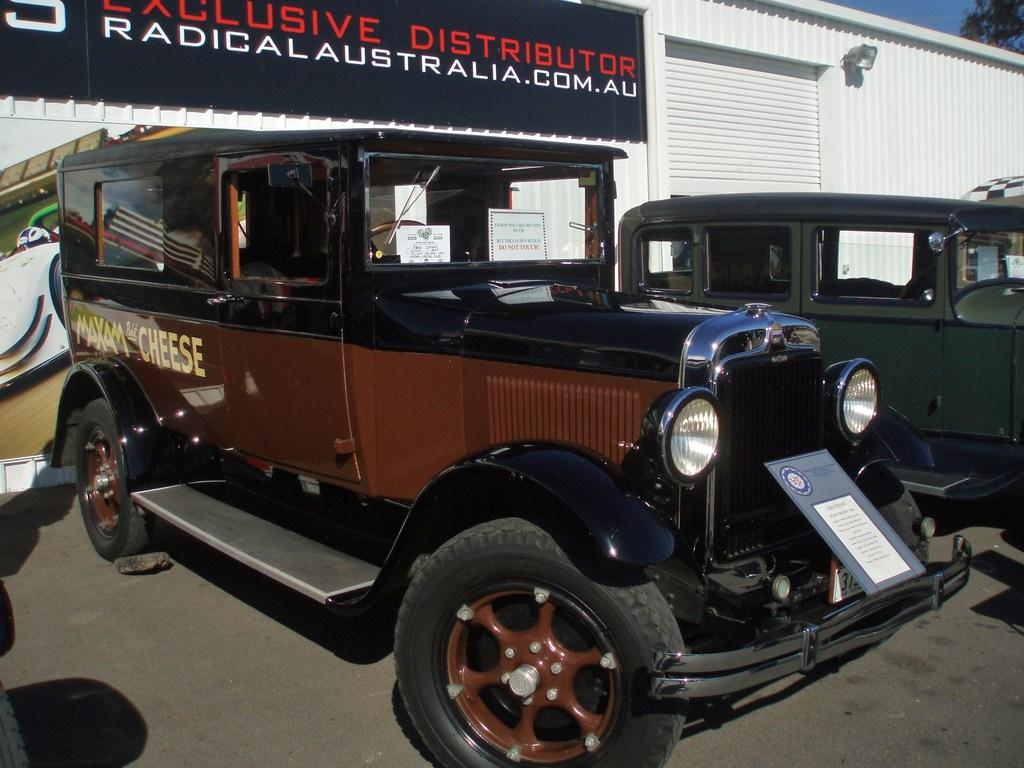What can be seen on the road in the image? There are vehicles on the road in the image. What else is visible in the image besides the vehicles? There is a board visible in the image. What structure can be seen in the background of the image? There is a shed in the background of the image. What type of leather is used to make the feather in the image? There is no leather or feather present in the image. 